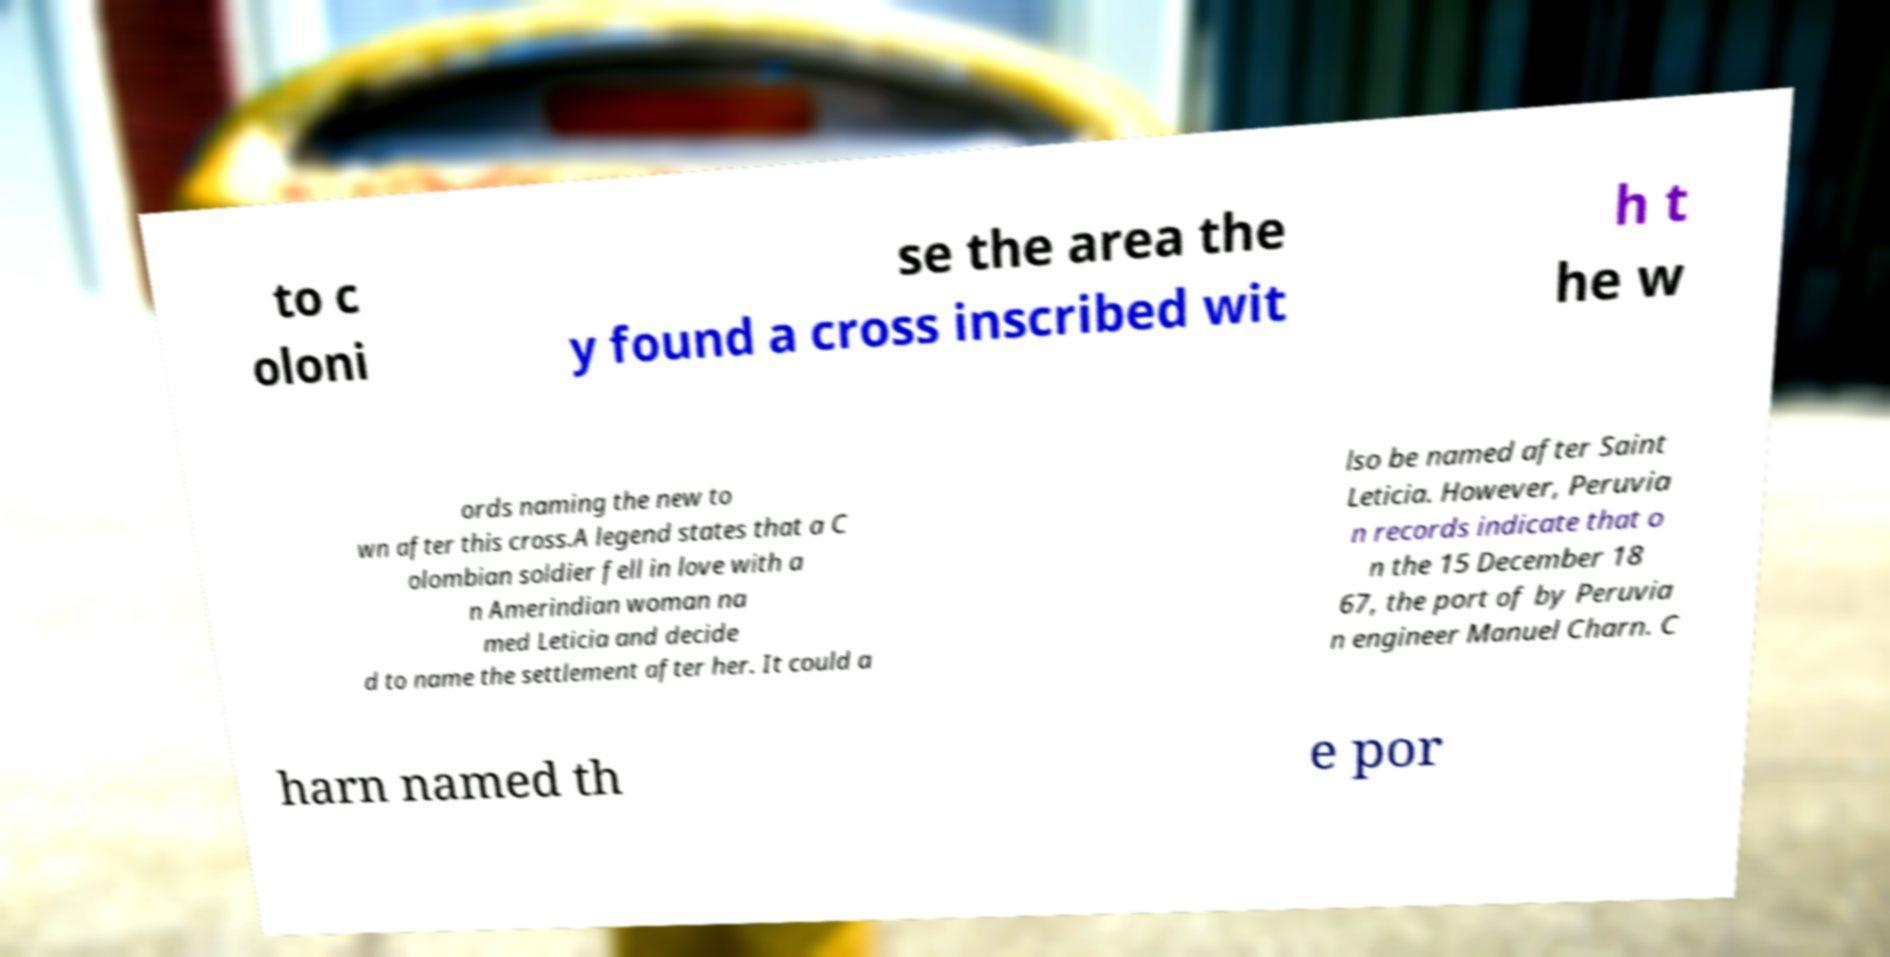Please read and relay the text visible in this image. What does it say? to c oloni se the area the y found a cross inscribed wit h t he w ords naming the new to wn after this cross.A legend states that a C olombian soldier fell in love with a n Amerindian woman na med Leticia and decide d to name the settlement after her. It could a lso be named after Saint Leticia. However, Peruvia n records indicate that o n the 15 December 18 67, the port of by Peruvia n engineer Manuel Charn. C harn named th e por 